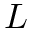Convert formula to latex. <formula><loc_0><loc_0><loc_500><loc_500>L</formula> 